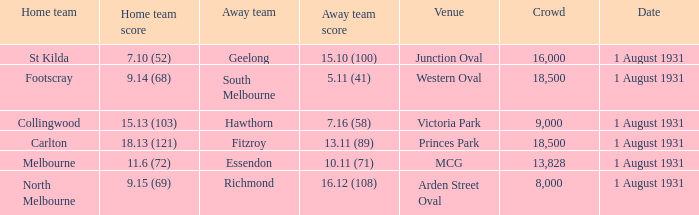What is the home teams score at Victoria Park? 15.13 (103). 